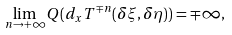Convert formula to latex. <formula><loc_0><loc_0><loc_500><loc_500>\lim _ { n \to + \infty } Q ( d _ { x } T ^ { \mp n } ( \delta \xi , \delta \eta ) ) = \mp \infty ,</formula> 